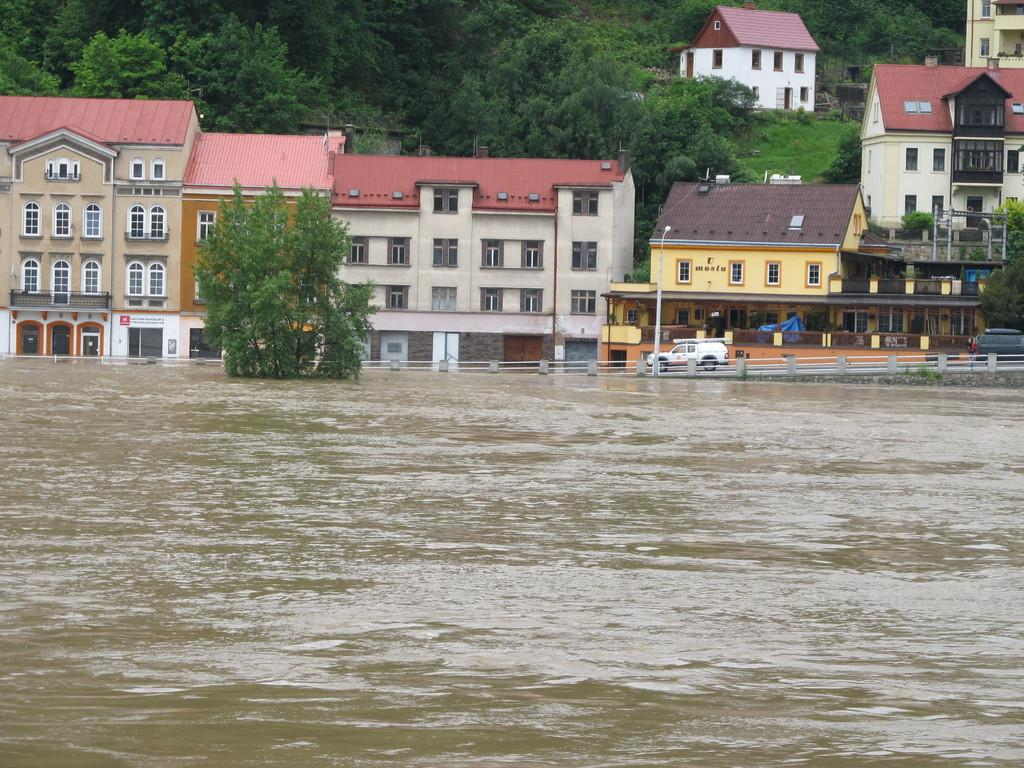What type of structures can be seen in the image? There are buildings in the image. What natural elements are present in the image? There are trees and water visible in the image. What man-made objects can be seen in the image? There are vehicles in the image. What type of passenger is being offered care in the image? There is no passenger or care being offered in the image; it only features buildings, trees, water, and vehicles. 